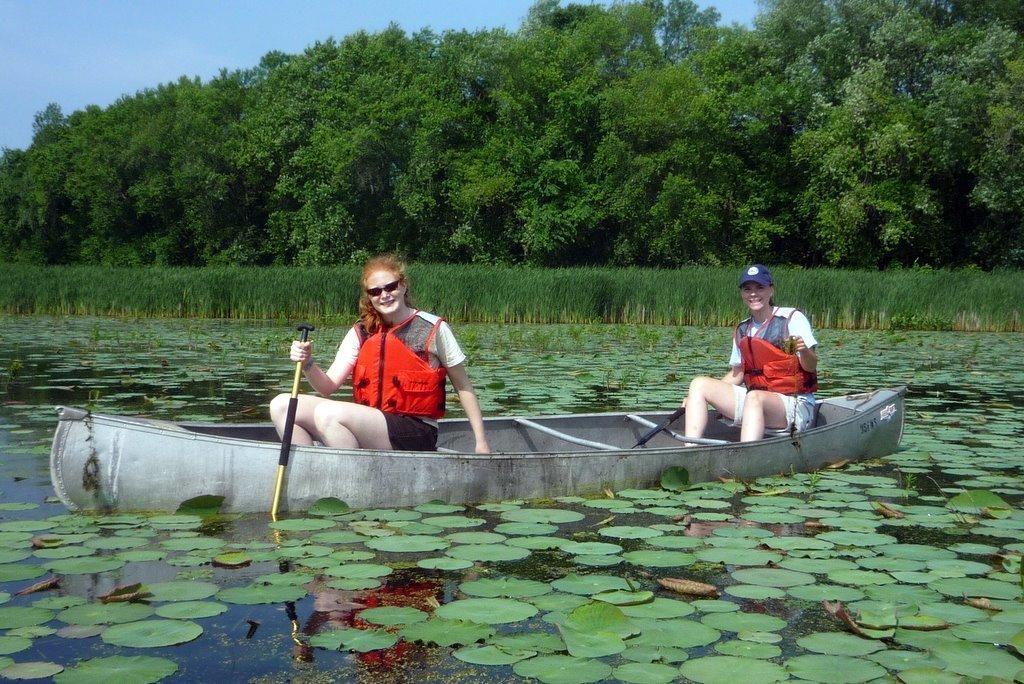Could you give a brief overview of what you see in this image? In this image I can see two persons sitting in the boat and the persons are wearing red color jacket and holding two sticks, background I can see trees and grass in green color and the sky is in blue color. 